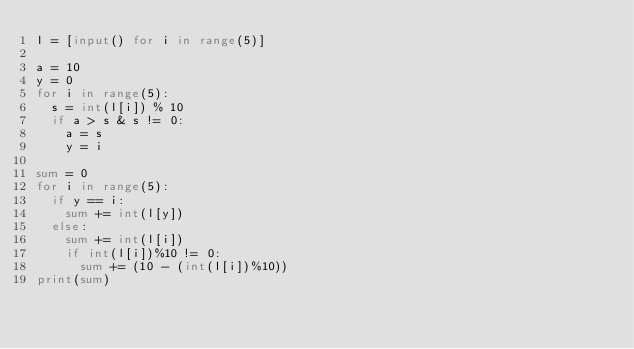Convert code to text. <code><loc_0><loc_0><loc_500><loc_500><_Python_>l = [input() for i in range(5)]

a = 10
y = 0
for i in range(5):
  s = int(l[i]) % 10
  if a > s & s != 0:
    a = s
    y = i
    
sum = 0
for i in range(5):
  if y == i:
    sum += int(l[y])
  else:
    sum += int(l[i])
    if int(l[i])%10 != 0:
      sum += (10 - (int(l[i])%10))
print(sum)</code> 